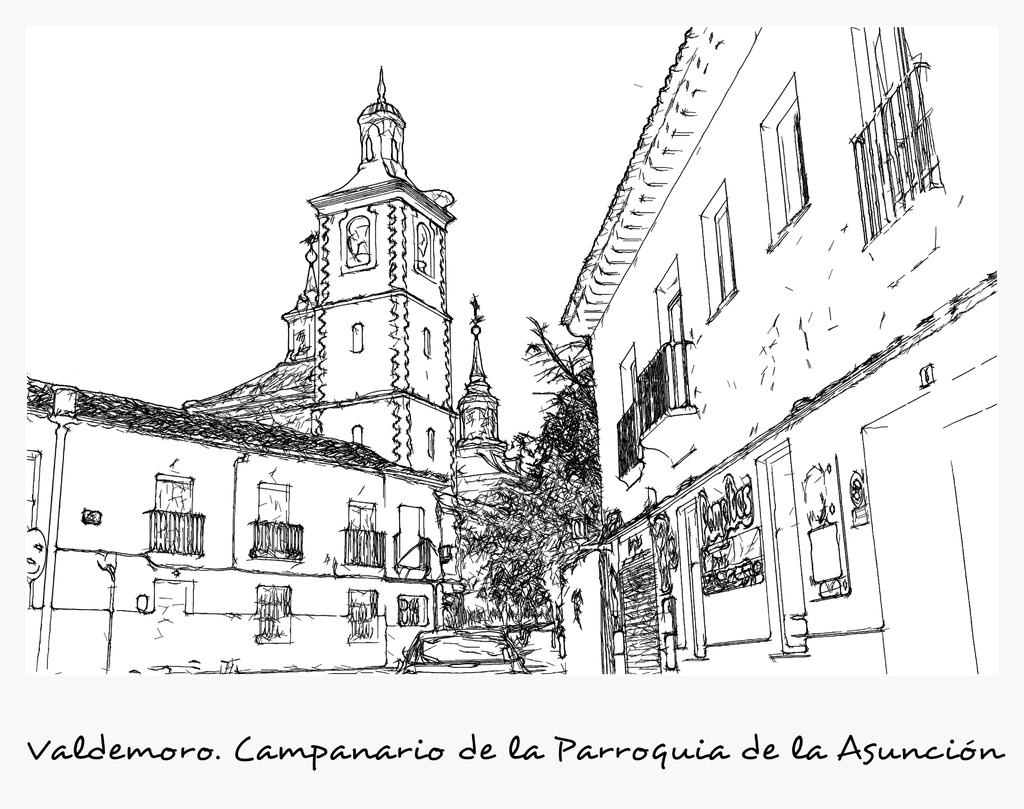What type of drawings are present in the image? The image contains drawings of buildings and trees. Can you describe the content of the drawings? The drawings depict buildings and trees. Is there any text present in the image? Yes, there is text written on the image. What type of punishment is depicted in the image? There is no punishment depicted in the image; it contains drawings of buildings and trees, along with text. 